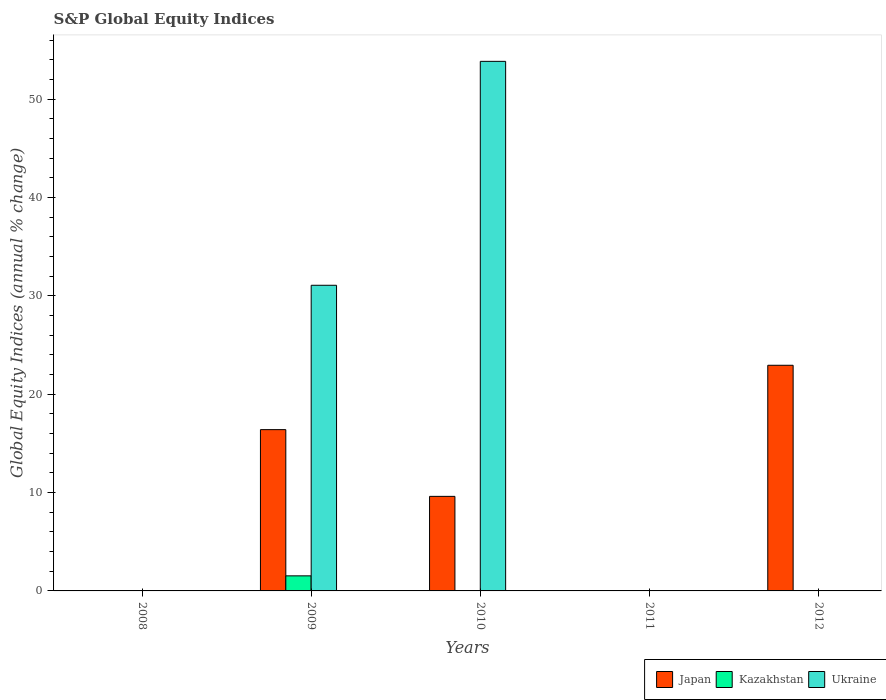How many different coloured bars are there?
Keep it short and to the point. 3. Are the number of bars on each tick of the X-axis equal?
Provide a succinct answer. No. How many bars are there on the 1st tick from the left?
Provide a succinct answer. 0. Across all years, what is the maximum global equity indices in Japan?
Make the answer very short. 22.94. In which year was the global equity indices in Kazakhstan maximum?
Your answer should be very brief. 2009. What is the total global equity indices in Ukraine in the graph?
Provide a short and direct response. 84.92. What is the difference between the global equity indices in Ukraine in 2009 and that in 2010?
Your response must be concise. -22.77. What is the difference between the global equity indices in Kazakhstan in 2008 and the global equity indices in Ukraine in 2009?
Keep it short and to the point. -31.08. What is the average global equity indices in Kazakhstan per year?
Your answer should be compact. 0.31. In the year 2009, what is the difference between the global equity indices in Kazakhstan and global equity indices in Japan?
Provide a short and direct response. -14.87. What is the ratio of the global equity indices in Japan in 2009 to that in 2010?
Keep it short and to the point. 1.71. What is the difference between the highest and the second highest global equity indices in Japan?
Provide a succinct answer. 6.54. What is the difference between the highest and the lowest global equity indices in Ukraine?
Keep it short and to the point. 53.84. How many bars are there?
Give a very brief answer. 6. What is the difference between two consecutive major ticks on the Y-axis?
Keep it short and to the point. 10. Are the values on the major ticks of Y-axis written in scientific E-notation?
Your answer should be very brief. No. Does the graph contain grids?
Provide a short and direct response. No. Where does the legend appear in the graph?
Your answer should be very brief. Bottom right. How many legend labels are there?
Give a very brief answer. 3. How are the legend labels stacked?
Give a very brief answer. Horizontal. What is the title of the graph?
Your answer should be very brief. S&P Global Equity Indices. Does "Greenland" appear as one of the legend labels in the graph?
Ensure brevity in your answer.  No. What is the label or title of the Y-axis?
Provide a short and direct response. Global Equity Indices (annual % change). What is the Global Equity Indices (annual % change) in Japan in 2008?
Your answer should be compact. 0. What is the Global Equity Indices (annual % change) in Ukraine in 2008?
Give a very brief answer. 0. What is the Global Equity Indices (annual % change) in Japan in 2009?
Offer a terse response. 16.4. What is the Global Equity Indices (annual % change) of Kazakhstan in 2009?
Your response must be concise. 1.53. What is the Global Equity Indices (annual % change) in Ukraine in 2009?
Your response must be concise. 31.08. What is the Global Equity Indices (annual % change) of Japan in 2010?
Give a very brief answer. 9.61. What is the Global Equity Indices (annual % change) in Ukraine in 2010?
Keep it short and to the point. 53.84. What is the Global Equity Indices (annual % change) in Japan in 2012?
Your answer should be compact. 22.94. What is the Global Equity Indices (annual % change) of Kazakhstan in 2012?
Your answer should be very brief. 0. What is the Global Equity Indices (annual % change) of Ukraine in 2012?
Offer a terse response. 0. Across all years, what is the maximum Global Equity Indices (annual % change) in Japan?
Your answer should be compact. 22.94. Across all years, what is the maximum Global Equity Indices (annual % change) of Kazakhstan?
Your response must be concise. 1.53. Across all years, what is the maximum Global Equity Indices (annual % change) of Ukraine?
Keep it short and to the point. 53.84. Across all years, what is the minimum Global Equity Indices (annual % change) of Japan?
Offer a very short reply. 0. What is the total Global Equity Indices (annual % change) of Japan in the graph?
Ensure brevity in your answer.  48.95. What is the total Global Equity Indices (annual % change) in Kazakhstan in the graph?
Your answer should be compact. 1.53. What is the total Global Equity Indices (annual % change) in Ukraine in the graph?
Your response must be concise. 84.92. What is the difference between the Global Equity Indices (annual % change) of Japan in 2009 and that in 2010?
Offer a very short reply. 6.78. What is the difference between the Global Equity Indices (annual % change) in Ukraine in 2009 and that in 2010?
Make the answer very short. -22.77. What is the difference between the Global Equity Indices (annual % change) of Japan in 2009 and that in 2012?
Your answer should be very brief. -6.54. What is the difference between the Global Equity Indices (annual % change) in Japan in 2010 and that in 2012?
Keep it short and to the point. -13.33. What is the difference between the Global Equity Indices (annual % change) in Japan in 2009 and the Global Equity Indices (annual % change) in Ukraine in 2010?
Provide a short and direct response. -37.44. What is the difference between the Global Equity Indices (annual % change) of Kazakhstan in 2009 and the Global Equity Indices (annual % change) of Ukraine in 2010?
Your answer should be very brief. -52.31. What is the average Global Equity Indices (annual % change) of Japan per year?
Ensure brevity in your answer.  9.79. What is the average Global Equity Indices (annual % change) in Kazakhstan per year?
Make the answer very short. 0.31. What is the average Global Equity Indices (annual % change) of Ukraine per year?
Offer a very short reply. 16.98. In the year 2009, what is the difference between the Global Equity Indices (annual % change) in Japan and Global Equity Indices (annual % change) in Kazakhstan?
Ensure brevity in your answer.  14.87. In the year 2009, what is the difference between the Global Equity Indices (annual % change) in Japan and Global Equity Indices (annual % change) in Ukraine?
Make the answer very short. -14.68. In the year 2009, what is the difference between the Global Equity Indices (annual % change) of Kazakhstan and Global Equity Indices (annual % change) of Ukraine?
Provide a succinct answer. -29.54. In the year 2010, what is the difference between the Global Equity Indices (annual % change) in Japan and Global Equity Indices (annual % change) in Ukraine?
Provide a short and direct response. -44.23. What is the ratio of the Global Equity Indices (annual % change) of Japan in 2009 to that in 2010?
Offer a terse response. 1.71. What is the ratio of the Global Equity Indices (annual % change) of Ukraine in 2009 to that in 2010?
Offer a very short reply. 0.58. What is the ratio of the Global Equity Indices (annual % change) in Japan in 2009 to that in 2012?
Your answer should be very brief. 0.71. What is the ratio of the Global Equity Indices (annual % change) in Japan in 2010 to that in 2012?
Keep it short and to the point. 0.42. What is the difference between the highest and the second highest Global Equity Indices (annual % change) in Japan?
Provide a succinct answer. 6.54. What is the difference between the highest and the lowest Global Equity Indices (annual % change) in Japan?
Your answer should be very brief. 22.94. What is the difference between the highest and the lowest Global Equity Indices (annual % change) of Kazakhstan?
Provide a short and direct response. 1.53. What is the difference between the highest and the lowest Global Equity Indices (annual % change) of Ukraine?
Make the answer very short. 53.84. 